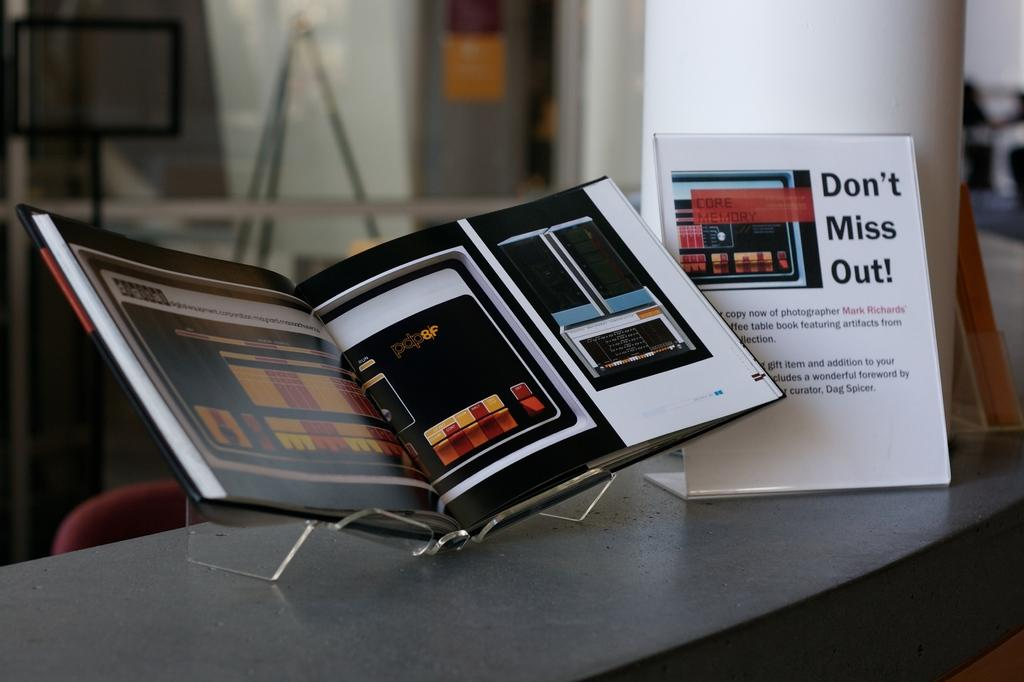<image>
Describe the image concisely. a book with the words don't miss out on it 